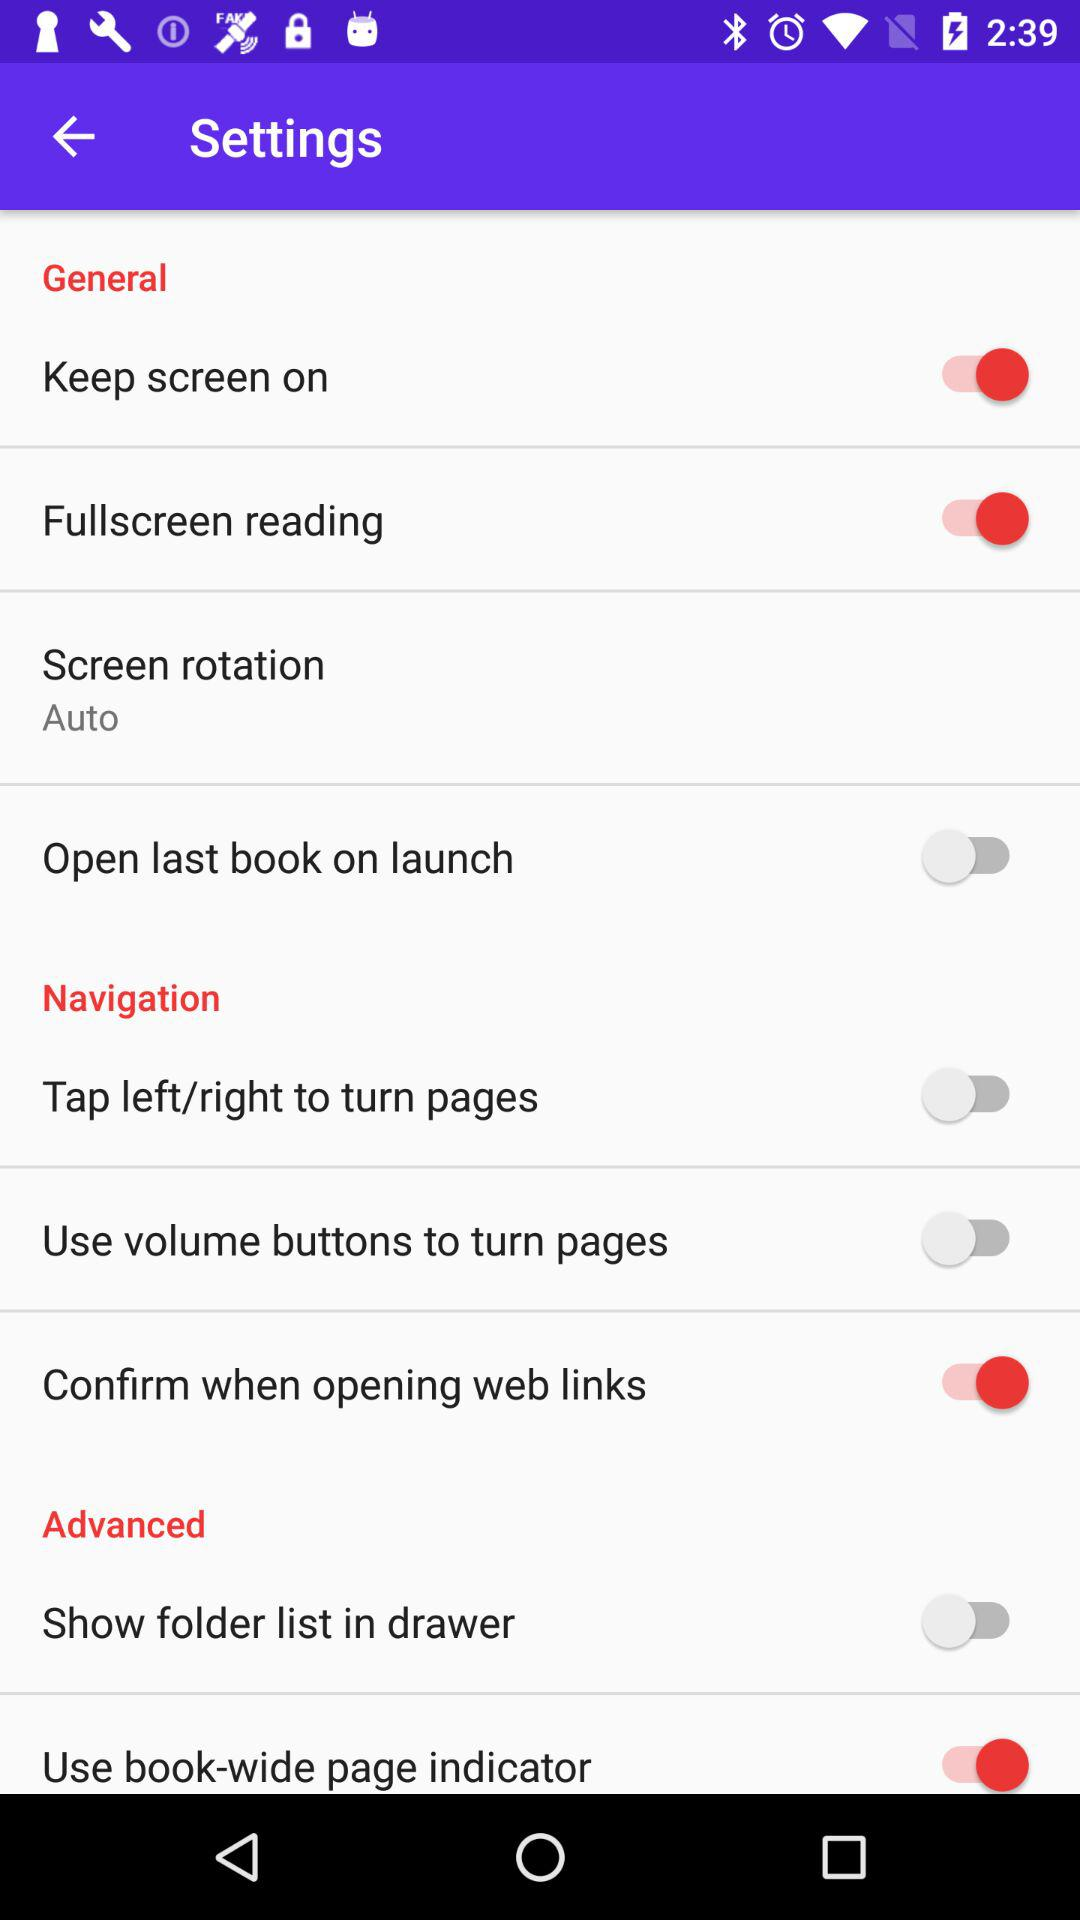How many items are in the Navigation section?
Answer the question using a single word or phrase. 3 